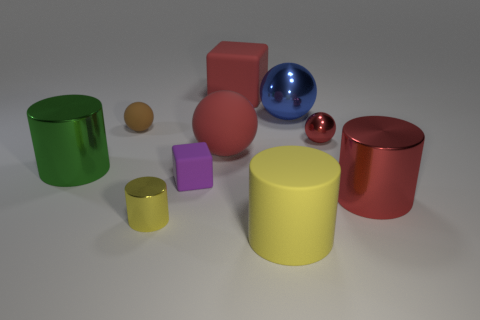There is a large rubber object that is the same color as the large matte sphere; what shape is it?
Your answer should be compact. Cube. What is the size of the shiny object that is the same color as the big rubber cylinder?
Offer a very short reply. Small. Do the rubber object that is in front of the tiny yellow cylinder and the big red object to the right of the red matte cube have the same shape?
Offer a very short reply. Yes. How many other things are there of the same color as the big block?
Give a very brief answer. 3. There is a rubber block that is behind the brown matte object; is it the same size as the tiny yellow metal cylinder?
Your response must be concise. No. Does the yellow object to the right of the red rubber sphere have the same material as the large block behind the blue ball?
Provide a short and direct response. Yes. Is there a yellow matte object of the same size as the brown rubber thing?
Make the answer very short. No. The small matte object in front of the big ball on the left side of the metal object that is behind the tiny red metallic thing is what shape?
Provide a succinct answer. Cube. Is the number of blue metallic objects on the left side of the large green object greater than the number of big purple spheres?
Offer a terse response. No. Is there a large blue shiny object of the same shape as the purple object?
Your answer should be very brief. No. 